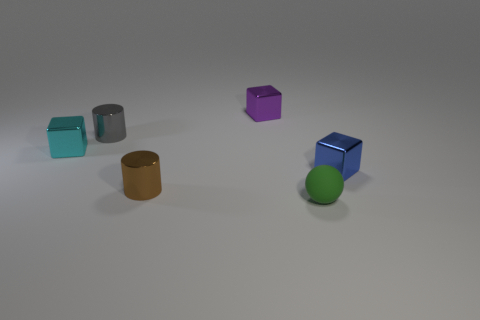What is the shape of the brown thing that is made of the same material as the small cyan object?
Offer a terse response. Cylinder. Is there anything else that is the same shape as the green matte object?
Keep it short and to the point. No. What is the color of the small metallic thing that is to the right of the brown metal cylinder and to the left of the blue cube?
Keep it short and to the point. Purple. What number of balls are purple objects or brown objects?
Keep it short and to the point. 0. How many gray things are the same size as the blue shiny thing?
Your response must be concise. 1. There is a shiny cylinder behind the tiny cyan metal block; how many small blocks are left of it?
Offer a very short reply. 1. How big is the cube that is to the left of the green rubber object and on the right side of the brown cylinder?
Make the answer very short. Small. Are there more tiny blue metallic things than tiny objects?
Offer a terse response. No. Is there a thing of the same color as the tiny rubber ball?
Keep it short and to the point. No. There is a cylinder in front of the cyan object; is it the same size as the gray metallic thing?
Offer a terse response. Yes. 